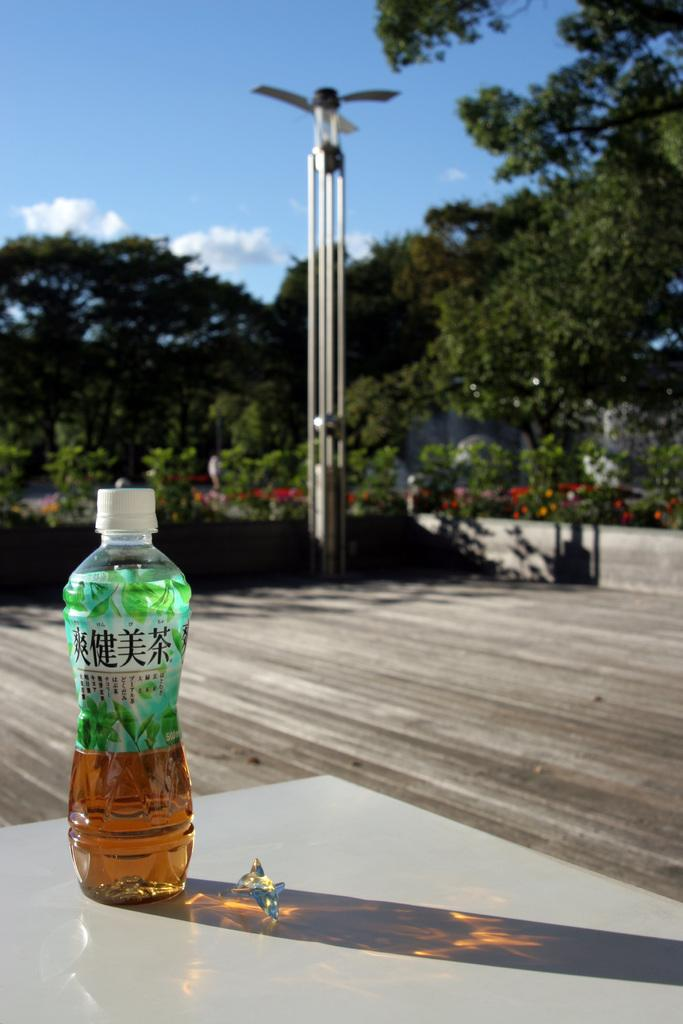What is in the bottle that is visible in the image? There is a drink in the bottle that is visible in the image. Where is the bottle placed in the image? The bottle is placed on a table in the image. What can be seen in the background of the image? In the background of the image, there is a path, a pole, trees, and the sky. What is the condition of the sky in the image? The sky is visible in the background of the image, and clouds are present. What type of punishment is being administered in the image? There is no punishment being administered in the image; it features a bottle with a drink on a table and various elements in the background. What color is the copper in the image? There is no copper present in the image. 